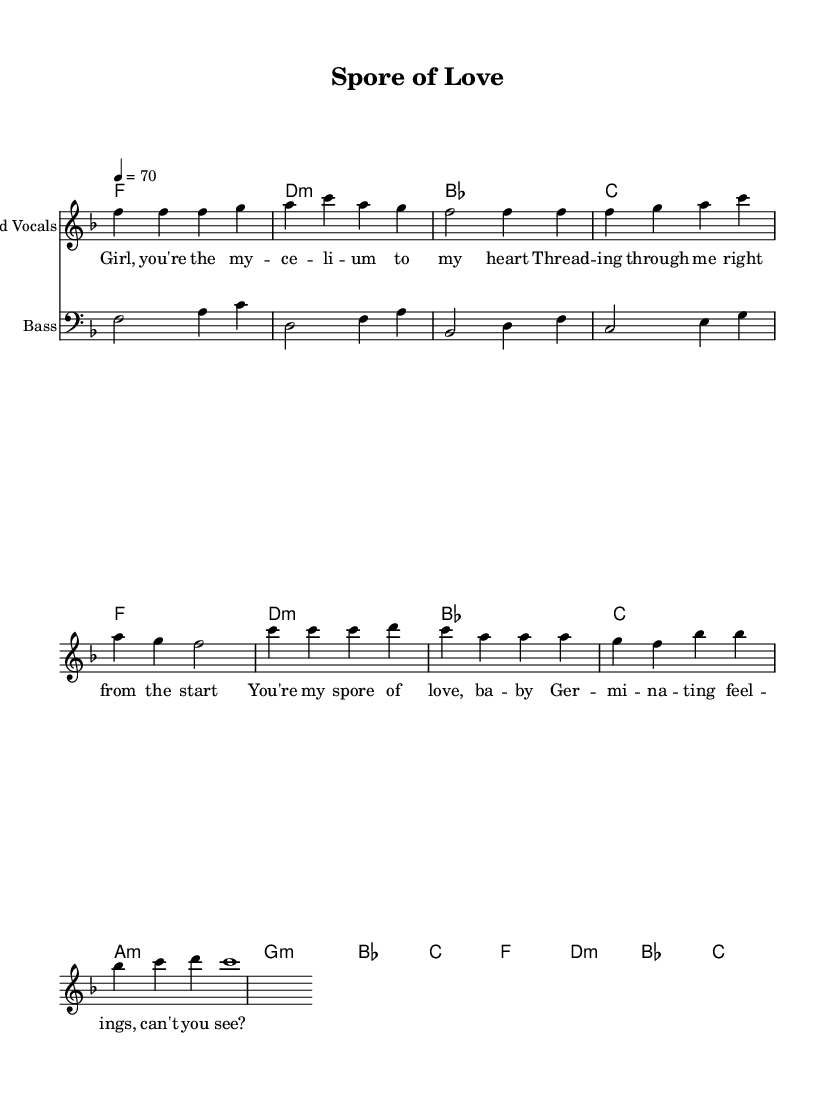What is the key signature of this music? The key signature is F major, which contains one flat. This is indicated by the flat sign on the B line of the staff.
Answer: F major What is the time signature of this music? The time signature is 4/4, which is denoted at the beginning of the score. This indicates there are four beats per measure, and the quarter note gets one beat.
Answer: 4/4 What is the tempo marking of this music? The tempo is set to 70 beats per minute, shown by the instruction "tempo 4 = 70" at the beginning of the score.
Answer: 70 Which chord is played for the first measure? The first measure contains the chord F, as indicated by the chord names above the staff. The chord names show which harmonies are used throughout the piece.
Answer: F How many bars are there in the melody section? Counting the measures in the melody line, there are eight bars in total. Each vertical line on the staff indicates a separate measure.
Answer: Eight What lyrical theme is present in the song? The song features a theme of love expressed with mycological terminology, particularly through the metaphor of "spore" and "germinating feelings." This shows how the lyrics cleverly incorporate mycology into a romantic context.
Answer: Love How does the use of mycology enhance the lyrical meaning? The mycological terms create metaphors for love and connection, intertwining scientific language with emotional expression. This adds depth to the lyrics and engages listeners on a playful level by connecting two seemingly different fields—science and romance.
Answer: Enhances depth 